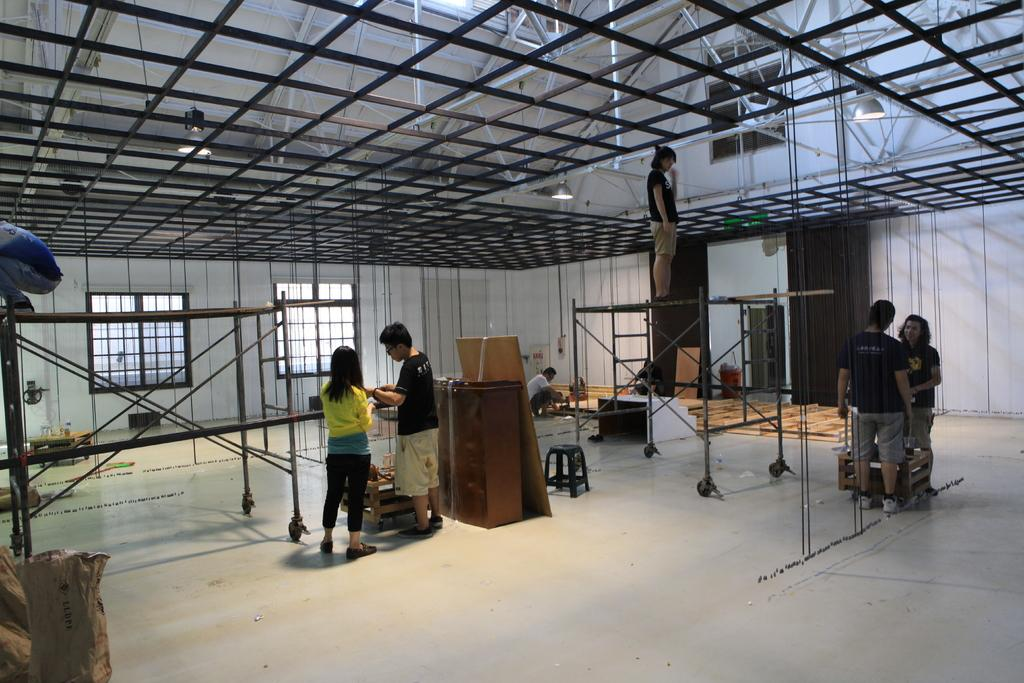Who or what is present in the image? There are people in the image. What architectural features can be seen in the image? There are windows, grills, lights, and poles to the roof in the image. What type of button can be seen on the school uniforms in the image? There is no mention of school uniforms or buttons in the image, so it is not possible to answer that question. 